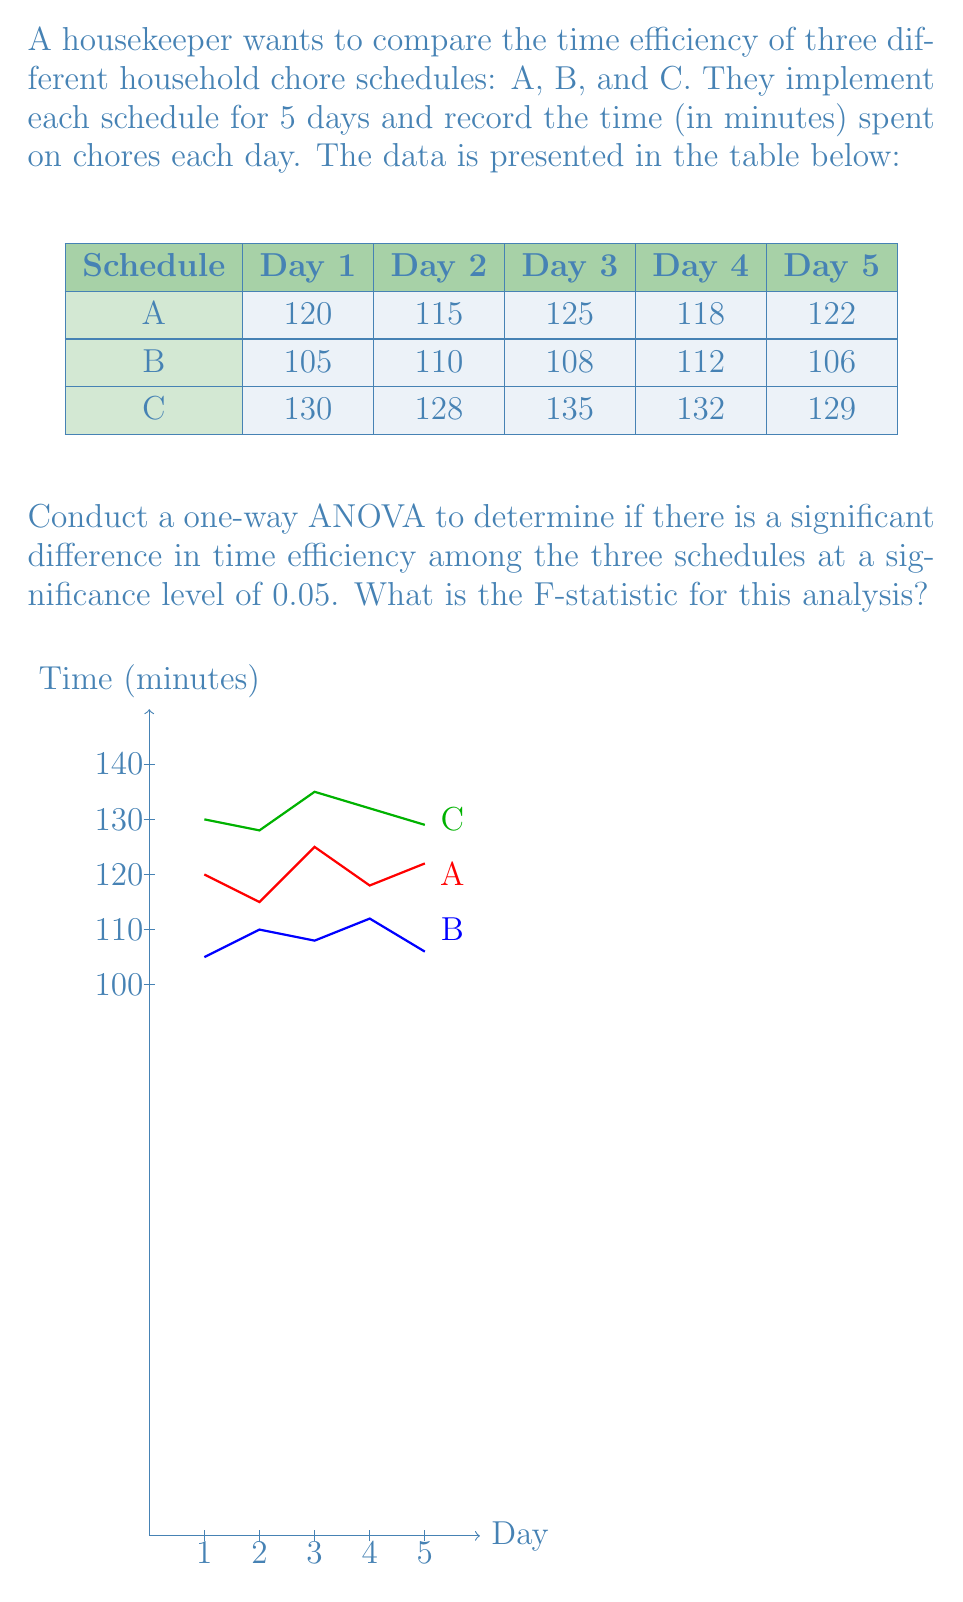Can you solve this math problem? To conduct a one-way ANOVA, we need to follow these steps:

1. Calculate the mean for each group (schedule):
   $$\bar{X}_A = \frac{120 + 115 + 125 + 118 + 122}{5} = 120$$
   $$\bar{X}_B = \frac{105 + 110 + 108 + 112 + 106}{5} = 108.2$$
   $$\bar{X}_C = \frac{130 + 128 + 135 + 132 + 129}{5} = 130.8$$

2. Calculate the grand mean:
   $$\bar{X} = \frac{120 + 108.2 + 130.8}{3} = 119.67$$

3. Calculate the Sum of Squares Between groups (SSB):
   $$SSB = 5[(120 - 119.67)^2 + (108.2 - 119.67)^2 + (130.8 - 119.67)^2] = 1624.13$$

4. Calculate the Sum of Squares Within groups (SSW):
   $$SSW_A = (120-120)^2 + (115-120)^2 + (125-120)^2 + (118-120)^2 + (122-120)^2 = 70$$
   $$SSW_B = (105-108.2)^2 + (110-108.2)^2 + (108-108.2)^2 + (112-108.2)^2 + (106-108.2)^2 = 36.8$$
   $$SSW_C = (130-130.8)^2 + (128-130.8)^2 + (135-130.8)^2 + (132-130.8)^2 + (129-130.8)^2 = 36.8$$
   $$SSW = 70 + 36.8 + 36.8 = 143.6$$

5. Calculate degrees of freedom:
   $$df_{between} = k - 1 = 3 - 1 = 2$$
   $$df_{within} = N - k = 15 - 3 = 12$$

6. Calculate Mean Square Between (MSB) and Mean Square Within (MSW):
   $$MSB = \frac{SSB}{df_{between}} = \frac{1624.13}{2} = 812.065$$
   $$MSW = \frac{SSW}{df_{within}} = \frac{143.6}{12} = 11.97$$

7. Calculate the F-statistic:
   $$F = \frac{MSB}{MSW} = \frac{812.065}{11.97} = 67.84$$

The F-statistic for this analysis is 67.84.
Answer: $F = 67.84$ 